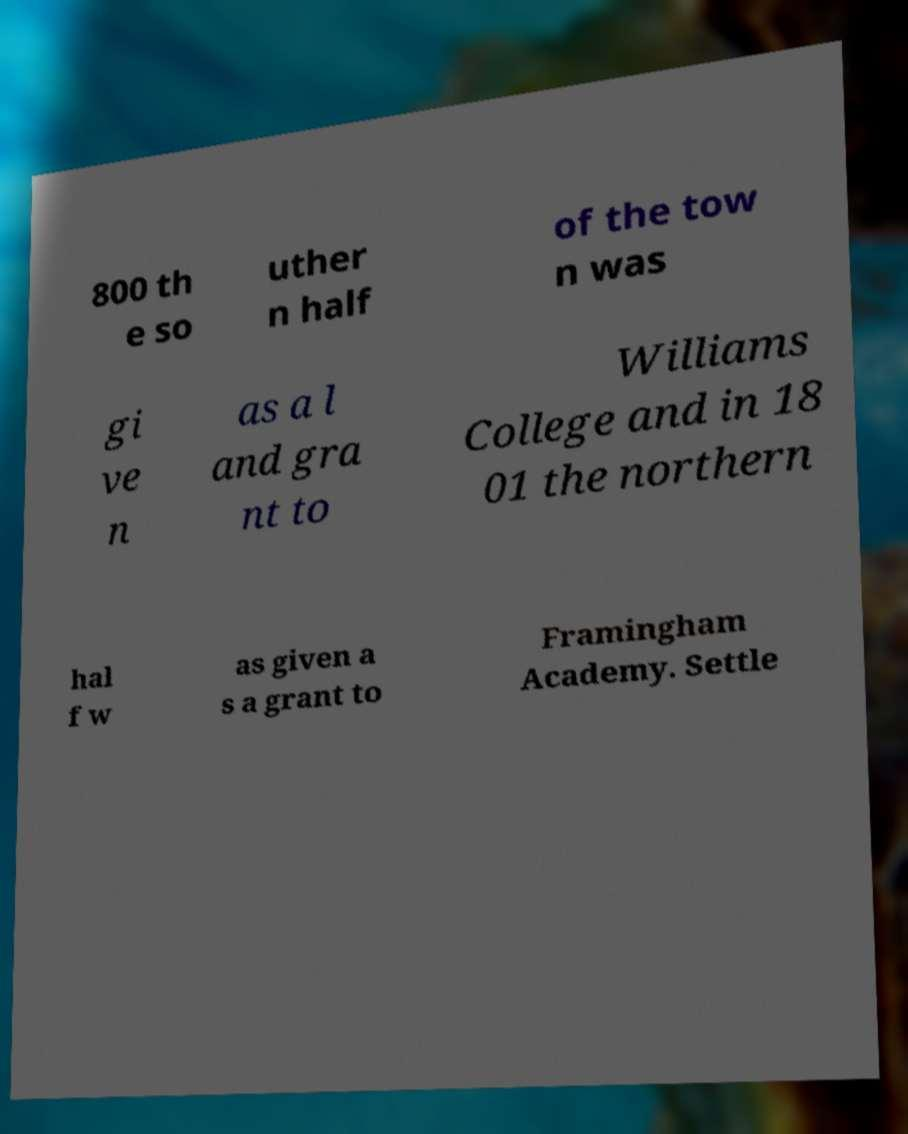Could you extract and type out the text from this image? 800 th e so uther n half of the tow n was gi ve n as a l and gra nt to Williams College and in 18 01 the northern hal f w as given a s a grant to Framingham Academy. Settle 